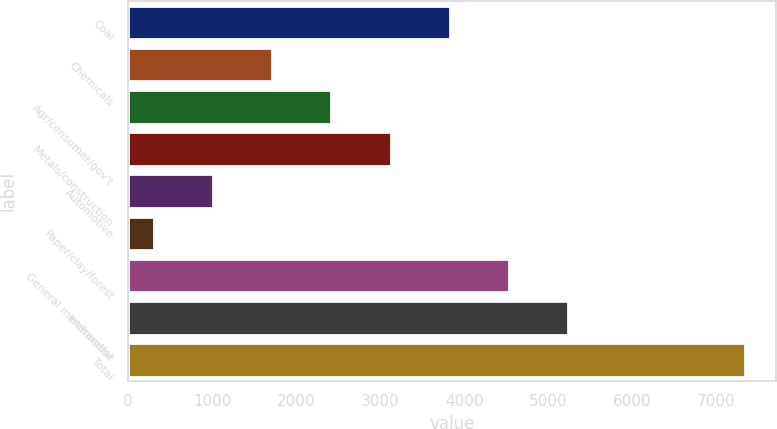Convert chart to OTSL. <chart><loc_0><loc_0><loc_500><loc_500><bar_chart><fcel>Coal<fcel>Chemicals<fcel>Agr/consumer/gov't<fcel>Metals/construction<fcel>Automotive<fcel>Paper/clay/forest<fcel>General merchandise<fcel>Intermodal<fcel>Total<nl><fcel>3825.15<fcel>1715.7<fcel>2418.85<fcel>3122<fcel>1012.55<fcel>309.4<fcel>4528.3<fcel>5231.45<fcel>7340.9<nl></chart> 